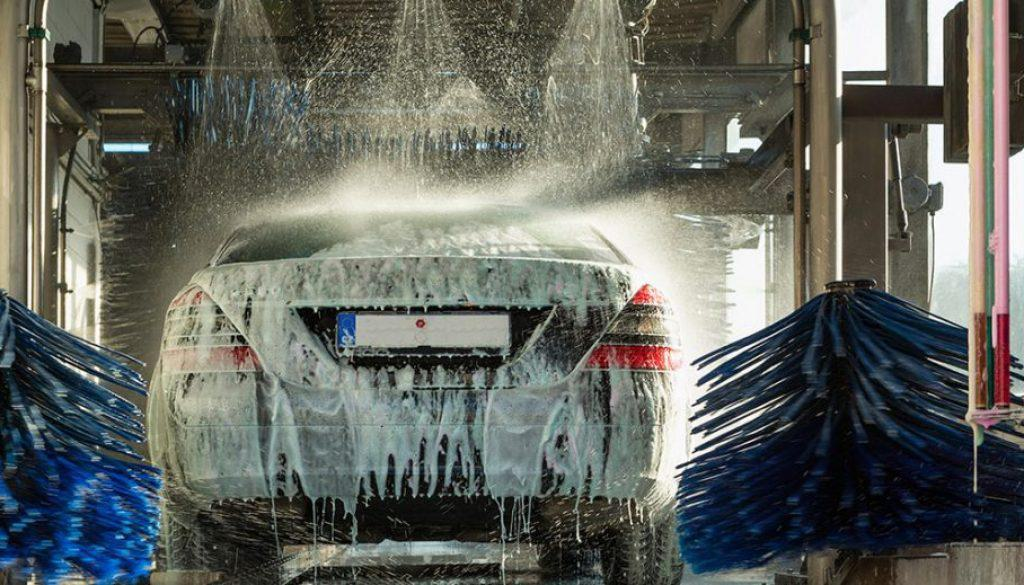Is there a car in the image? Yes 